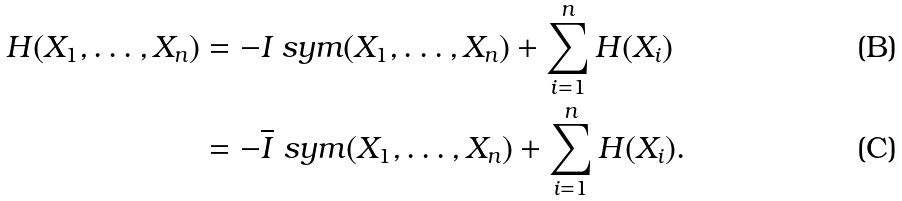Convert formula to latex. <formula><loc_0><loc_0><loc_500><loc_500>H ( X _ { 1 } , \dots , X _ { n } ) & = - I _ { \ } s y m ( X _ { 1 } , \dots , X _ { n } ) + \sum _ { i = 1 } ^ { n } H ( X _ { i } ) \\ & = - \overline { I } _ { \ } s y m ( X _ { 1 } , \dots , X _ { n } ) + \sum _ { i = 1 } ^ { n } H ( X _ { i } ) .</formula> 